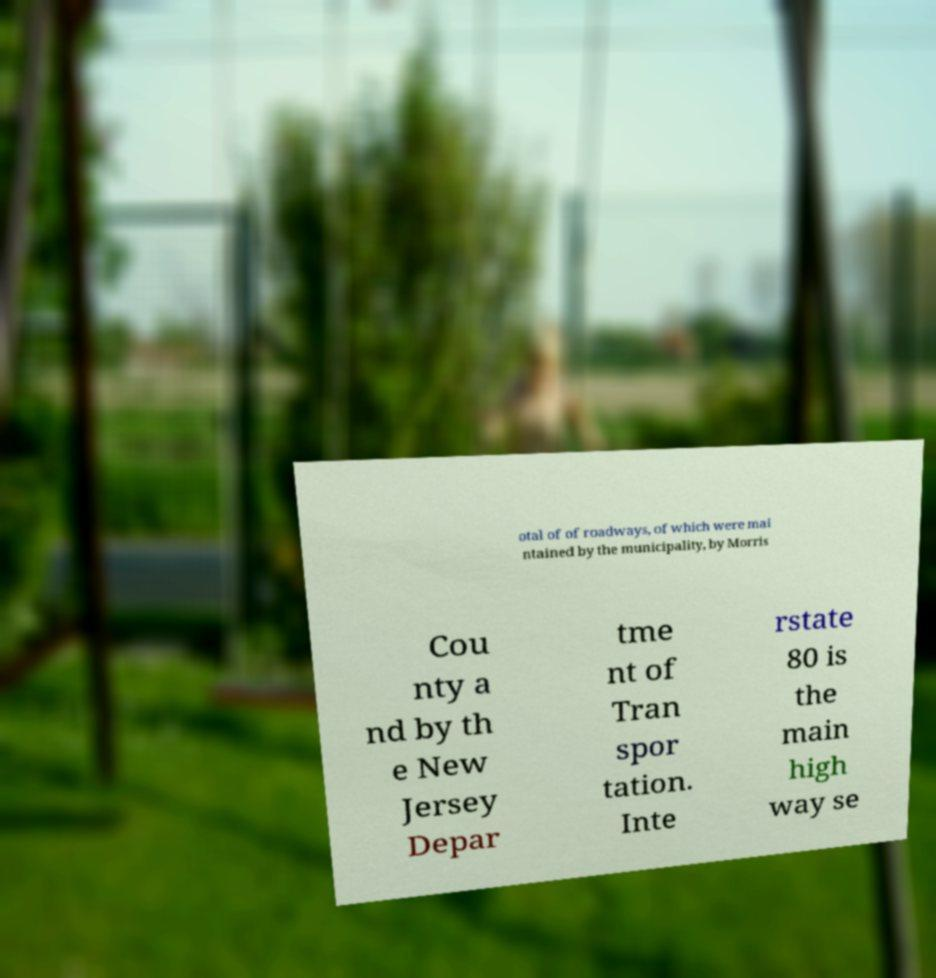Can you read and provide the text displayed in the image?This photo seems to have some interesting text. Can you extract and type it out for me? otal of of roadways, of which were mai ntained by the municipality, by Morris Cou nty a nd by th e New Jersey Depar tme nt of Tran spor tation. Inte rstate 80 is the main high way se 